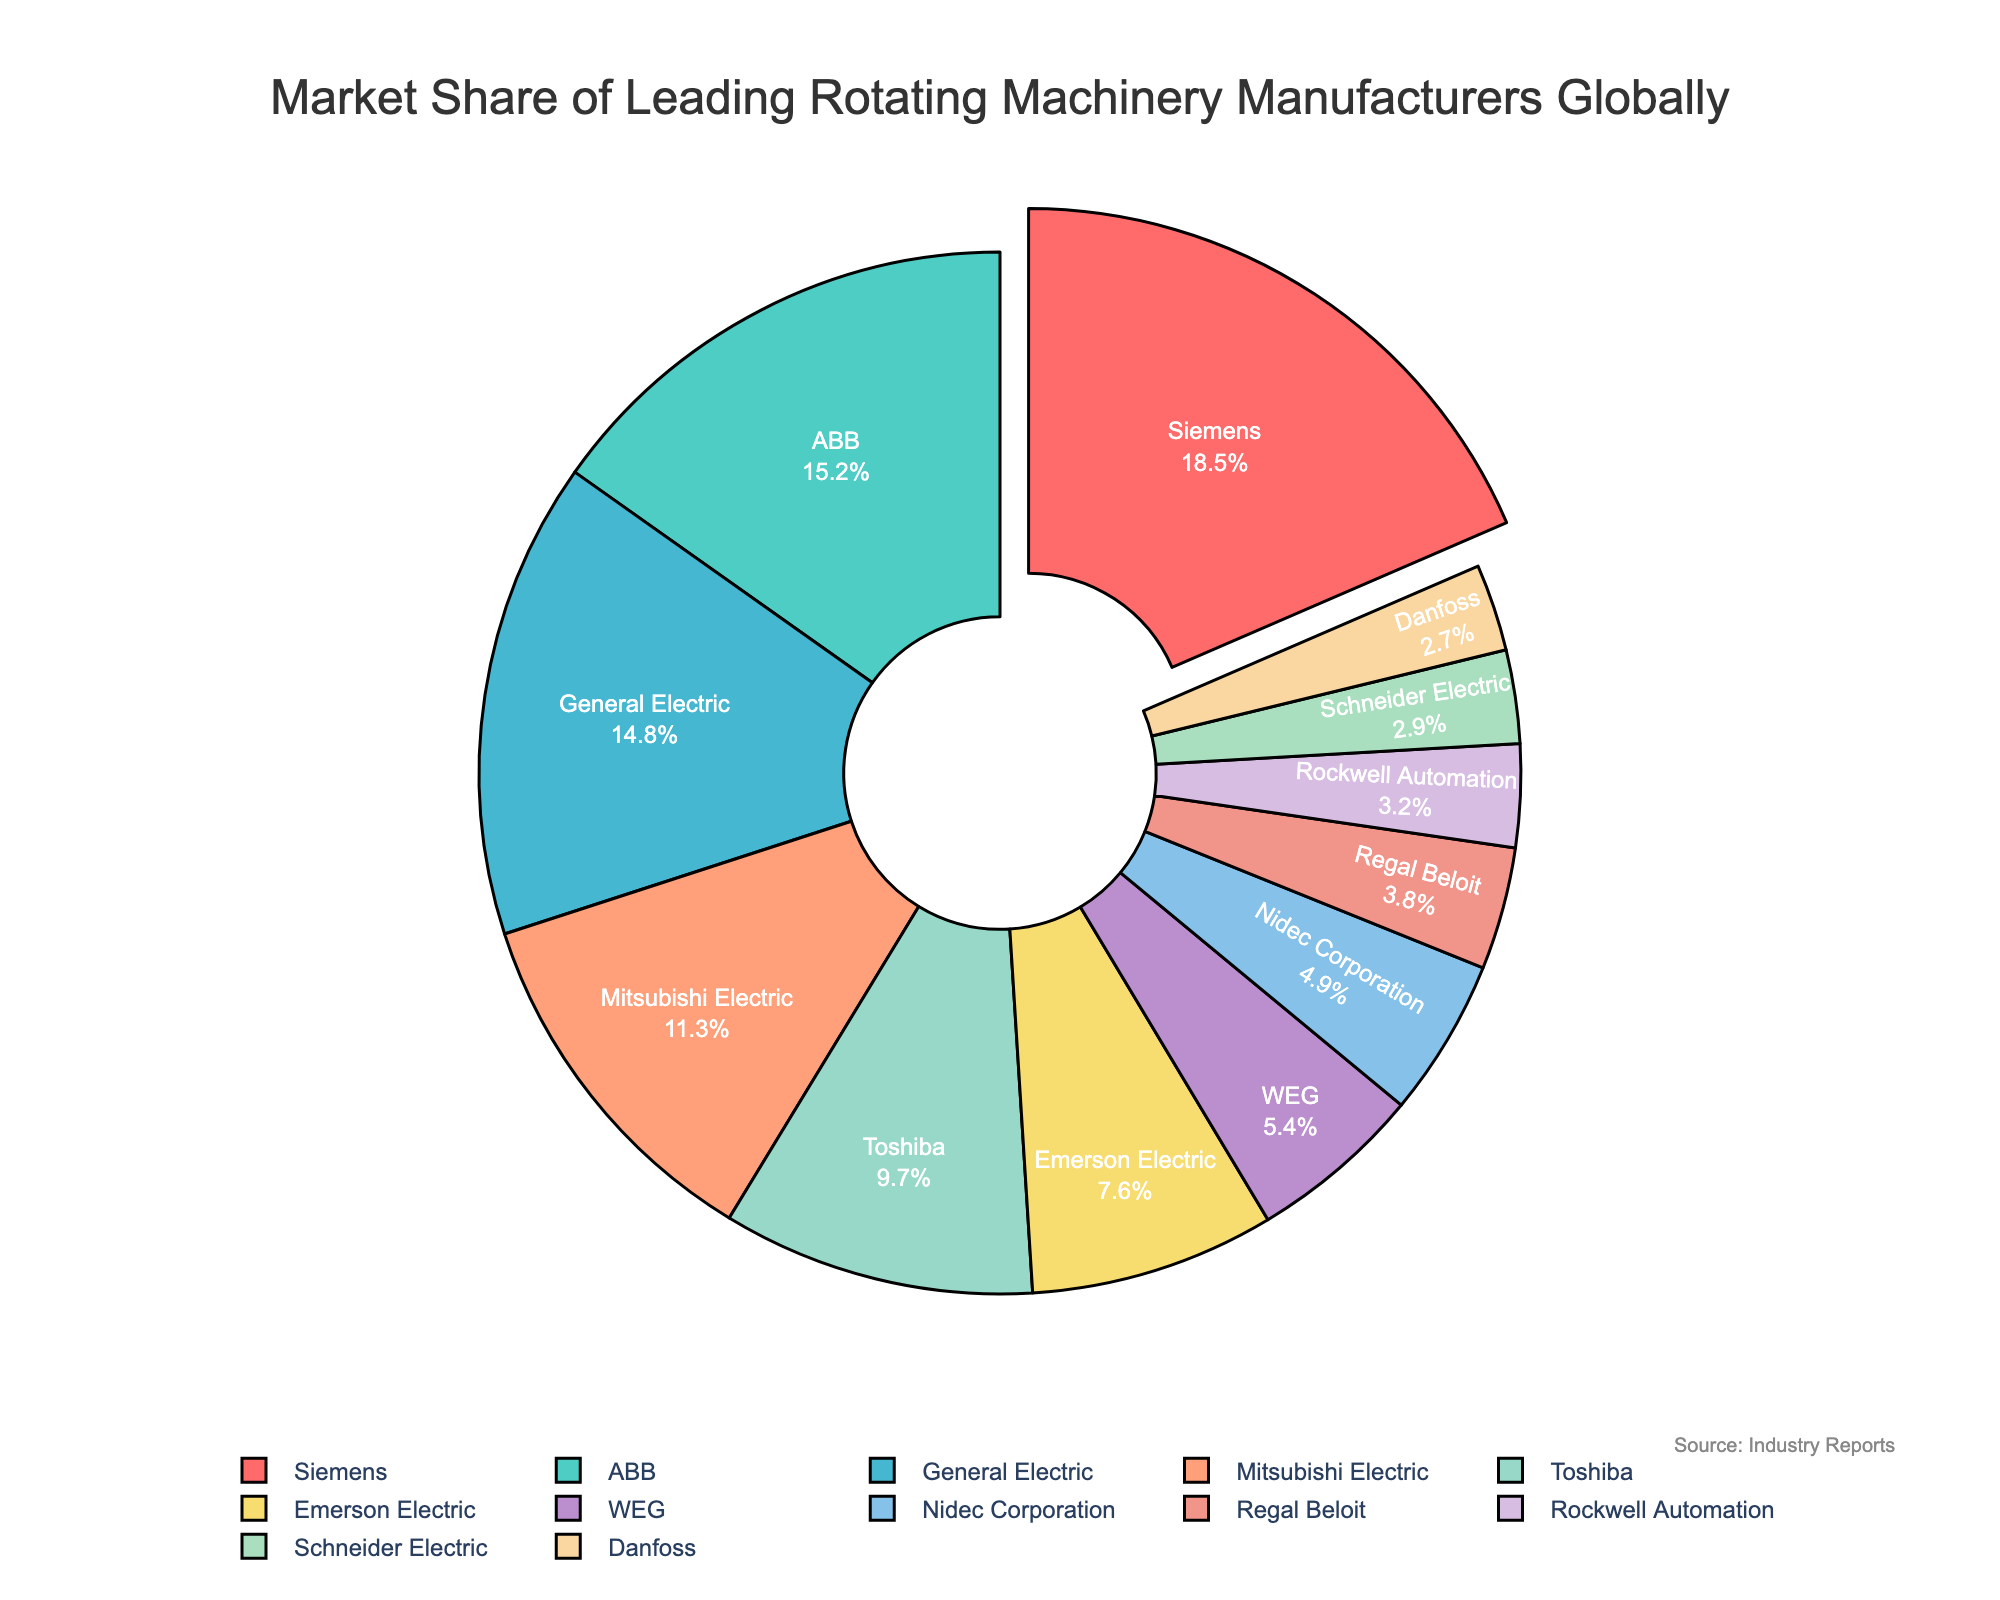What's the company with the largest market share? The pie chart highlights the segment representing Siemens pulled out, indicating it has the largest market share.
Answer: Siemens What is the combined market share of the top three companies? Siemens (18.5%), ABB (15.2%), and General Electric (14.8%) hold the top three shares. Summing these values gives 18.5 + 15.2 + 14.8 = 48.5%.
Answer: 48.5% Which company has a market share closest to 10%? The pie chart shows Toshiba with a 9.7% market share, which is the closest to 10%.
Answer: Toshiba How much more market share does Siemens have compared to Mitsubishi Electric? Siemens' market share is 18.5% and Mitsubishi Electric's is 11.3%. The difference is 18.5 - 11.3 = 7.2%.
Answer: 7.2% Which companies have a market share less than 5% but more than 3%? By examining the pie chart, WEG (5.4%), Nidec Corporation (4.9%), Regal Beloit (3.8%), and Rockwell Automation (3.2%) meet this criterion. Excluding those over 5%, we are left with Nidec Corporation, Regal Beloit, and Rockwell Automation.
Answer: Nidec Corporation, Regal Beloit, Rockwell Automation What is the total market share of the bottom five companies by market share? The companies with the smallest shares are Rockwell Automation (3.2%), Schneider Electric (2.9%), and Danfoss (2.7%). Summing these up gives 3.2 + 2.9 + 2.7 = 8.8%.
Answer: 8.8% Which segment is colored with the blue shade and what is its market share? The blue shade corresponds to General Electric with a market share of 14.8%.
Answer: General Electric, 14.8% What is the combined market share of the companies whose shares exceed 10%? Siemens (18.5%), ABB (15.2%), General Electric (14.8%), and Mitsubishi Electric (11.3%) exceed 10%. Summing these values gives 18.5 + 15.2 + 14.8 + 11.3 = 59.8%.
Answer: 59.8% Which company has the smallest market share and what is its value? The pie chart indicates that Danfoss has the smallest share with 2.7%.
Answer: Danfoss, 2.7% What percentage of the market do Toshiba and Emerson Electric control together? Toshiba has a market share of 9.7% and Emerson Electric has 7.6%. Summing these values gives 9.7 + 7.6 = 17.3%.
Answer: 17.3% 